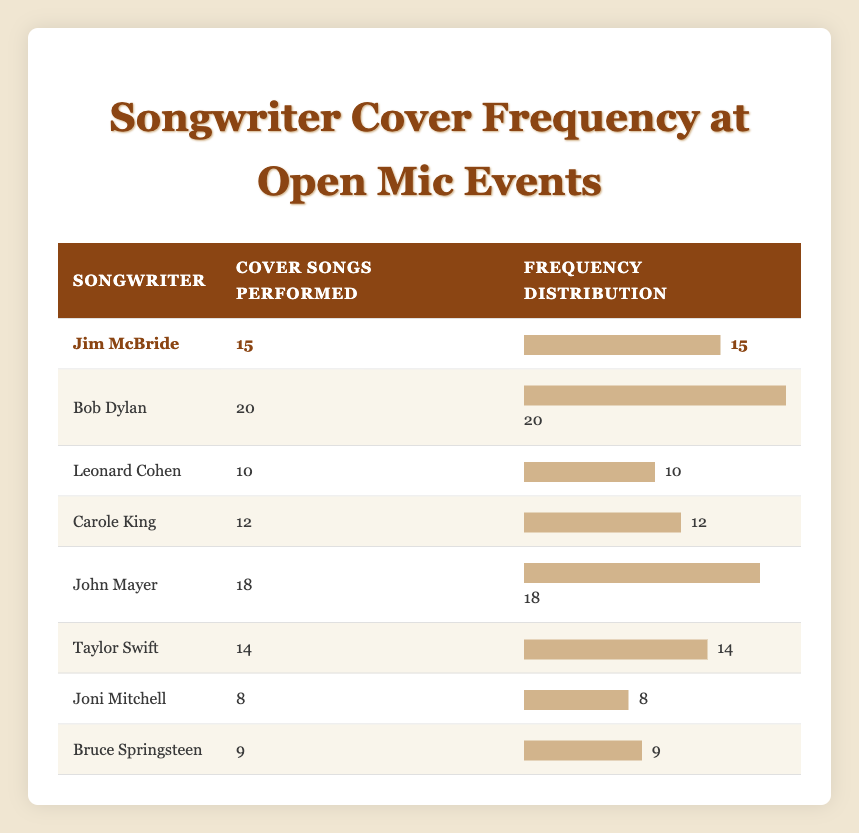What is the total number of cover songs performed for all songwriters? To find the total number of cover songs, I will add up the coverSongsPerformed column: 15 (Jim McBride) + 20 (Bob Dylan) + 10 (Leonard Cohen) + 12 (Carole King) + 18 (John Mayer) + 14 (Taylor Swift) + 8 (Joni Mitchell) + 9 (Bruce Springsteen) = 106
Answer: 106 Which songwriter has the highest number of cover songs performed? By comparing the values in the coverSongsPerformed column, Bob Dylan has 20, which is the largest number among all the songwriters listed
Answer: Bob Dylan Is Jim McBride among the top three songwriters in terms of cover songs performed? The top three songwriters in terms of cover songs performed are Bob Dylan (20), John Mayer (18), and Jim McBride (15). Since Jim McBride is third among them, the answer is yes
Answer: Yes What is the average number of cover songs performed by all songwriters? To calculate the average, add all cover songs performed (106) and divide by the number of songwriters (8): 106 / 8 = 13.25
Answer: 13.25 How many more cover songs were performed of John Mayer compared to Joni Mitchell? John Mayer performed 18 cover songs, while Joni Mitchell performed 8. The difference is 18 - 8 = 10
Answer: 10 Did Taylor Swift perform more cover songs than Leonard Cohen? Taylor Swift performed 14 cover songs and Leonard Cohen performed 10. Since 14 is greater than 10, the answer is yes
Answer: Yes What is the total number of cover songs performed by songwriters who have more than 15 songs? The songwriters who performed more than 15 songs are Bob Dylan (20) and John Mayer (18), totaling 20 + 18 = 38
Answer: 38 Which songwriter performed the least number of cover songs? Comparing the coverSongsPerformed, Joni Mitchell has the least with 8 cover songs
Answer: Joni Mitchell What percentage of cover songs performed does Jim McBride have out of the total? Jim McBride performed 15 songs out of a total of 106. To find the percentage: (15/106) * 100 = 14.15%. Rounding, this would be approximately 14%
Answer: 14% 